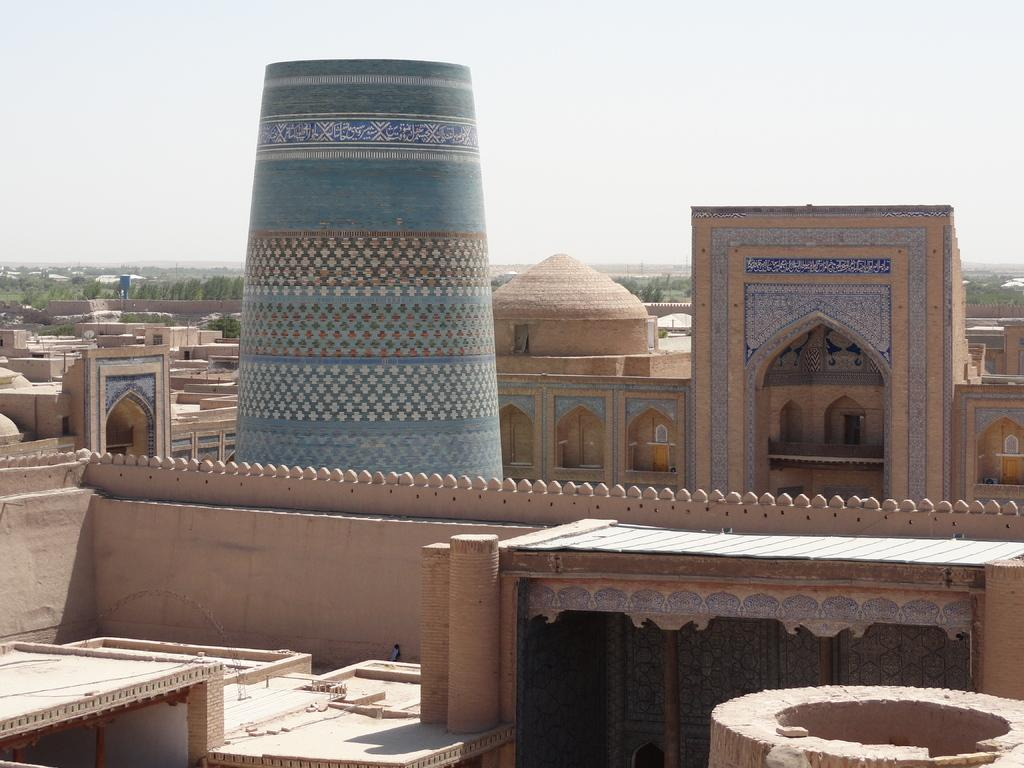What type of structure is visible in the image? There is a building in the image. What architectural feature can be seen on the building? There are arches in the image. What other structures are present in the image? There are houses in the image. What can be seen in the background of the image? There are trees in the background of the image. What type of oil can be seen dripping from the arches in the image? There is no oil present in the image. 